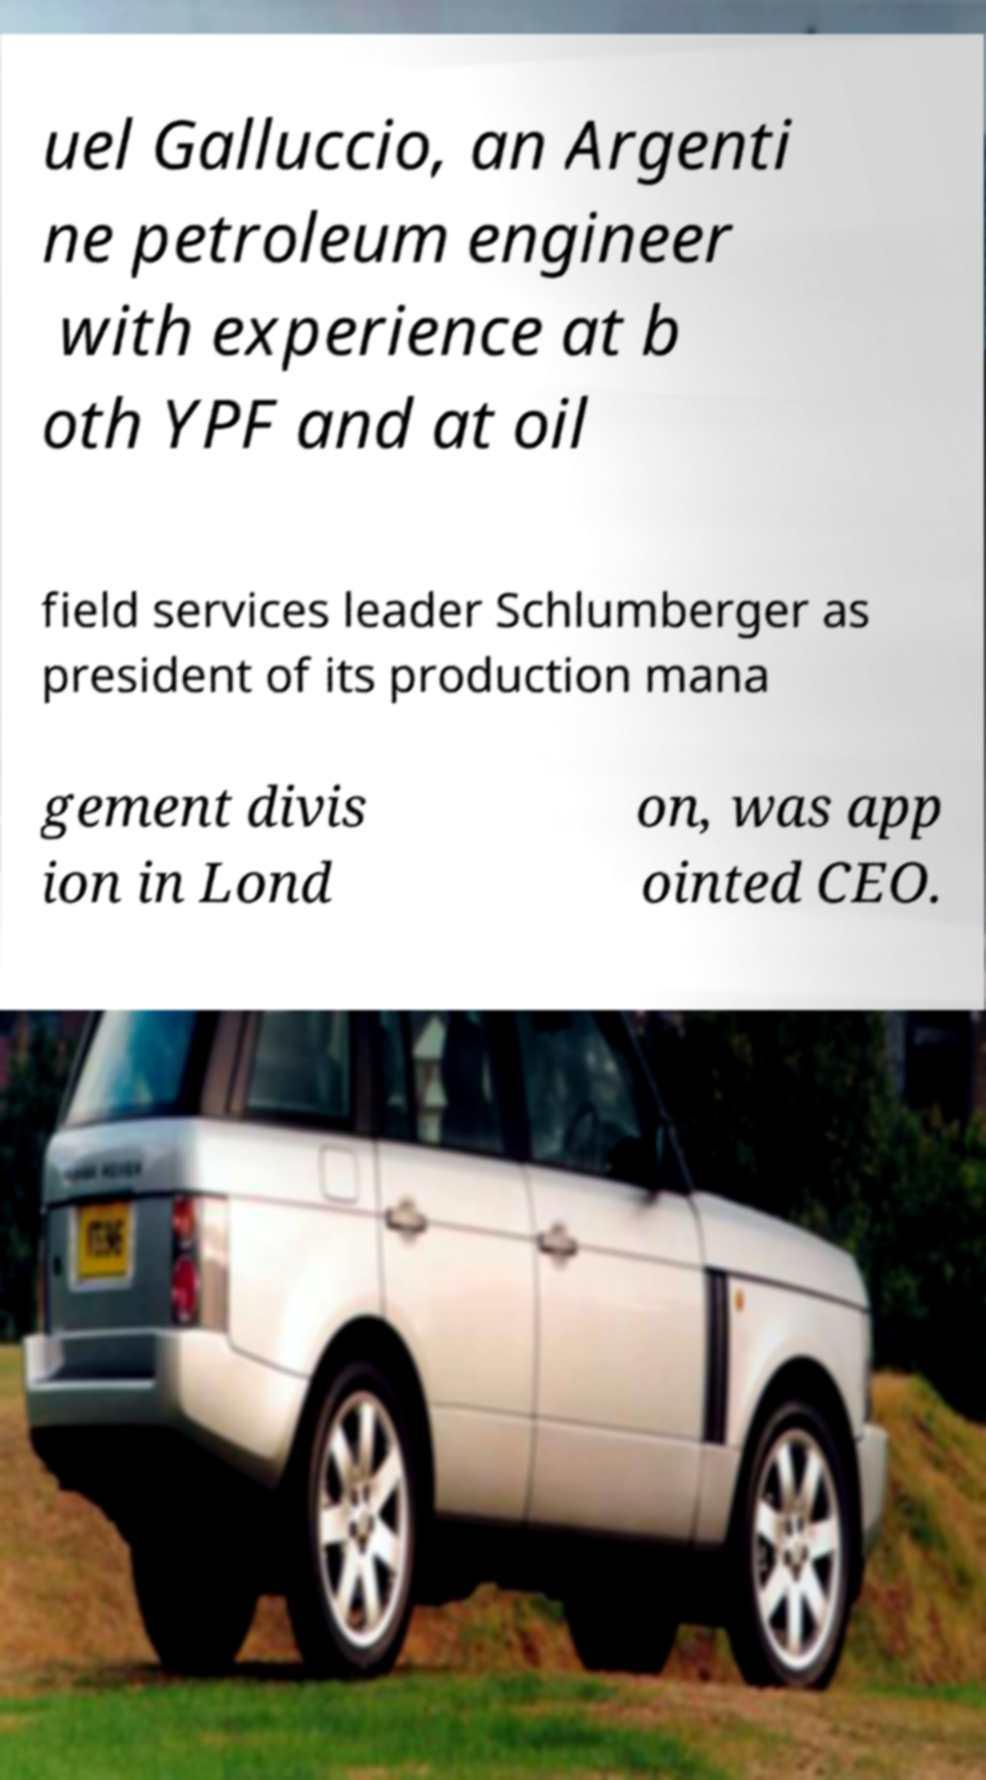Could you extract and type out the text from this image? uel Galluccio, an Argenti ne petroleum engineer with experience at b oth YPF and at oil field services leader Schlumberger as president of its production mana gement divis ion in Lond on, was app ointed CEO. 